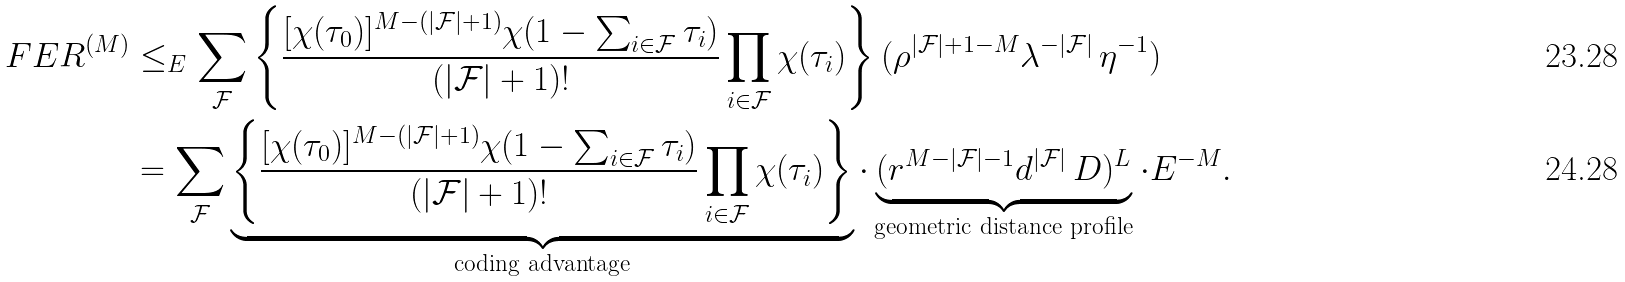Convert formula to latex. <formula><loc_0><loc_0><loc_500><loc_500>F E R ^ { ( M ) } & \leq _ { E } \sum _ { \mathcal { F } } \left \{ \frac { [ \chi ( \tau _ { 0 } ) ] ^ { M - ( | \mathcal { F } | + 1 ) } \chi ( 1 - \sum _ { i \in { \mathcal { F } } } \tau _ { i } ) } { ( | \mathcal { F } | + 1 ) ! } \prod _ { i \in { \mathcal { F } } } \chi ( \tau _ { i } ) \right \} ( \rho ^ { | \mathcal { F } | + 1 - M } \lambda ^ { - | \mathcal { F } | } \, \eta ^ { - 1 } ) \\ & = \sum _ { \mathcal { F } } \underbrace { \left \{ \frac { [ \chi ( \tau _ { 0 } ) ] ^ { M - ( | \mathcal { F } | + 1 ) } \chi ( 1 - \sum _ { i \in { \mathcal { F } } } \tau _ { i } ) } { ( | \mathcal { F } | + 1 ) ! } \prod _ { i \in { \mathcal { F } } } \chi ( \tau _ { i } ) \right \} } _ { \text {coding advantage} } \cdot \underbrace { ( r ^ { M - | \mathcal { F } | - 1 } d ^ { | \mathcal { F } | } \, D ) ^ { L } } _ { \text {geometric distance profile} } \cdot E ^ { - M } .</formula> 